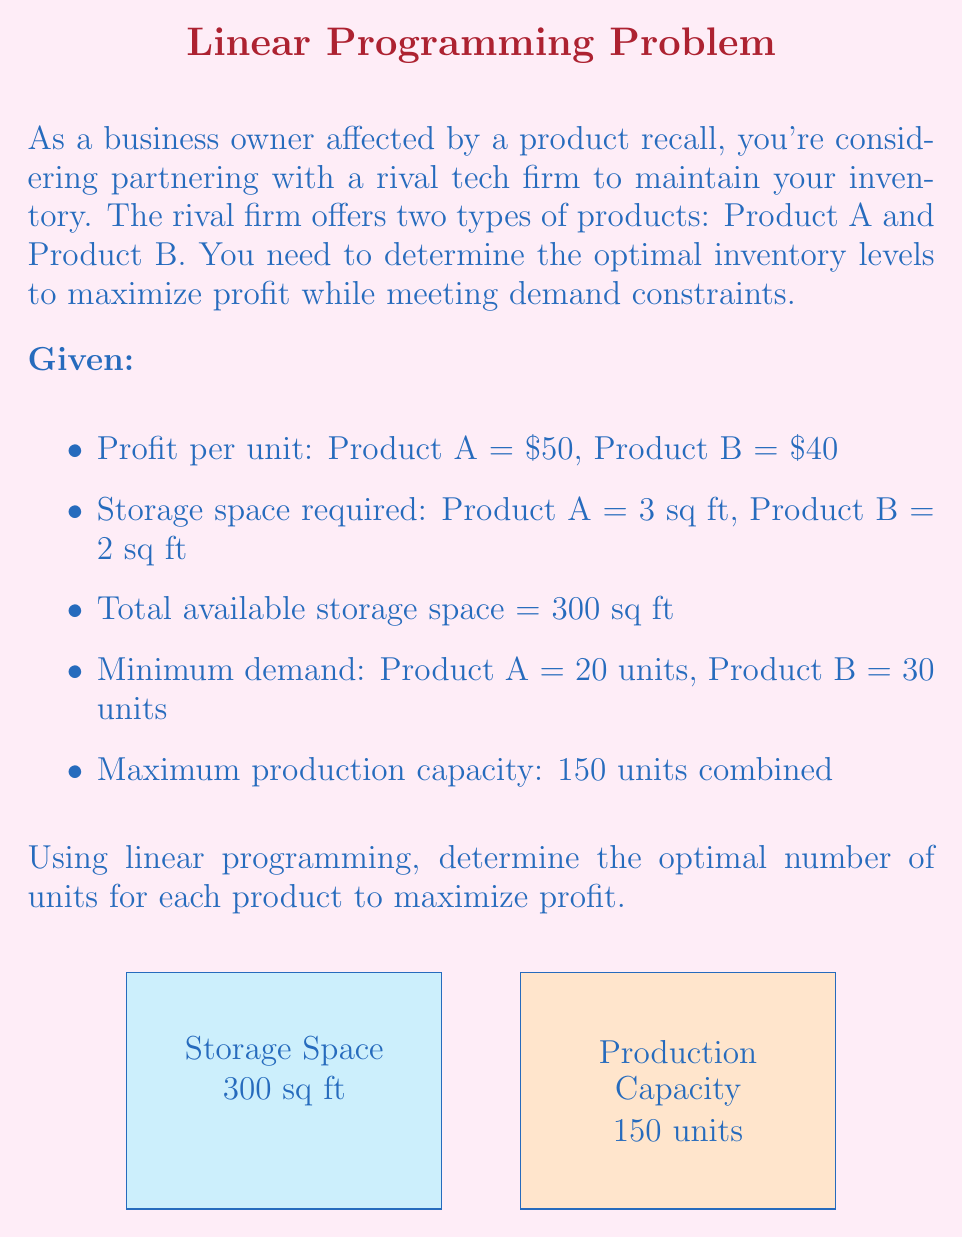Solve this math problem. Let's solve this problem using linear programming:

1) Define variables:
   Let $x$ = number of units of Product A
   Let $y$ = number of units of Product B

2) Objective function (maximize profit):
   $$ \text{Maximize } Z = 50x + 40y $$

3) Constraints:
   a) Storage space: $3x + 2y \leq 300$
   b) Minimum demand for A: $x \geq 20$
   c) Minimum demand for B: $y \geq 30$
   d) Production capacity: $x + y \leq 150$
   e) Non-negativity: $x \geq 0, y \geq 0$

4) Solve graphically or using the simplex method. In this case, we'll use the corner point method:

   Possible corner points:
   - (20, 30): Satisfies minimum demands
   - (20, 120): Max B while satisfying min A
   - (60, 90): Intersection of storage and capacity constraints
   - (100, 0): Max A possible with storage constraint
   - (150, 0): Max production capacity (violates storage)

5) Evaluate the objective function at each valid point:
   - (20, 30): $Z = 50(20) + 40(30) = 2200$
   - (20, 120): $Z = 50(20) + 40(120) = 5800$
   - (60, 90): $Z = 50(60) + 40(90) = 6600$
   - (100, 0): $Z = 50(100) + 40(0) = 5000$

6) The maximum value occurs at (60, 90), which satisfies all constraints.

Therefore, the optimal solution is to produce 60 units of Product A and 90 units of Product B.
Answer: 60 units of Product A, 90 units of Product B 